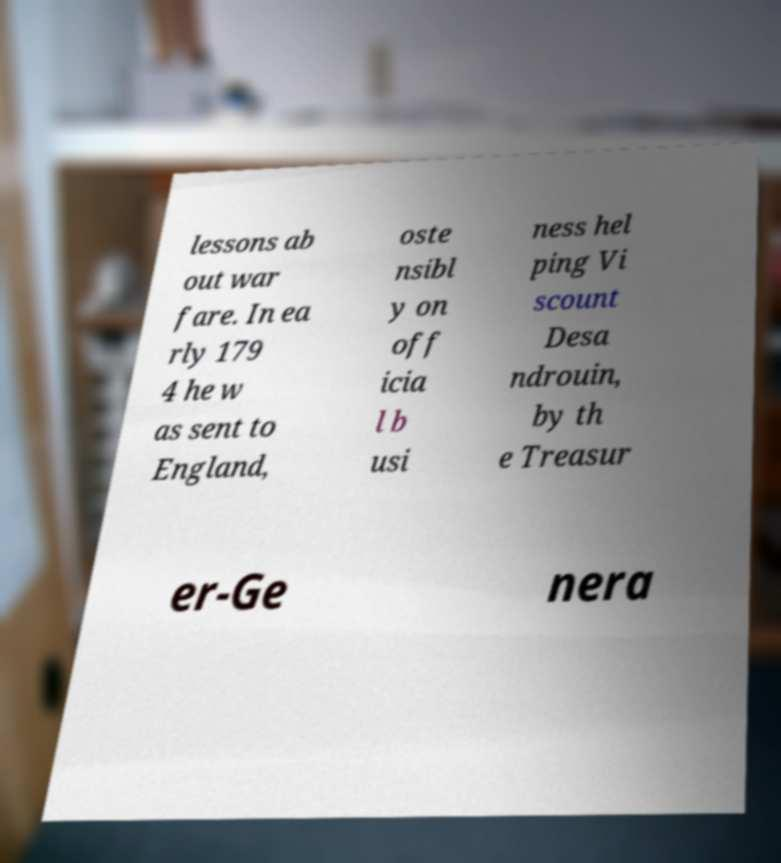There's text embedded in this image that I need extracted. Can you transcribe it verbatim? lessons ab out war fare. In ea rly 179 4 he w as sent to England, oste nsibl y on off icia l b usi ness hel ping Vi scount Desa ndrouin, by th e Treasur er-Ge nera 